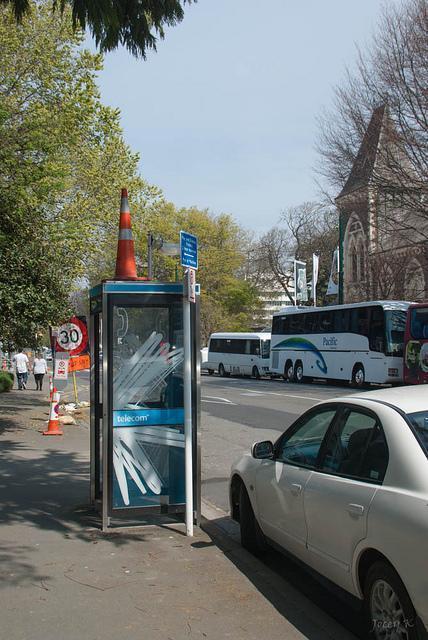Originally what was the glass booth designed for?
Choose the right answer from the provided options to respond to the question.
Options: Police monitoring, phone calls, sentry guard, toll taking. Phone calls. 